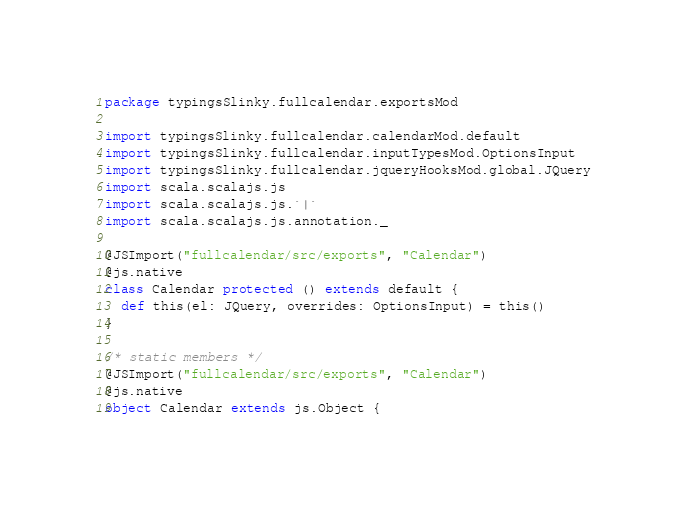<code> <loc_0><loc_0><loc_500><loc_500><_Scala_>package typingsSlinky.fullcalendar.exportsMod

import typingsSlinky.fullcalendar.calendarMod.default
import typingsSlinky.fullcalendar.inputTypesMod.OptionsInput
import typingsSlinky.fullcalendar.jqueryHooksMod.global.JQuery
import scala.scalajs.js
import scala.scalajs.js.`|`
import scala.scalajs.js.annotation._

@JSImport("fullcalendar/src/exports", "Calendar")
@js.native
class Calendar protected () extends default {
  def this(el: JQuery, overrides: OptionsInput) = this()
}

/* static members */
@JSImport("fullcalendar/src/exports", "Calendar")
@js.native
object Calendar extends js.Object {</code> 